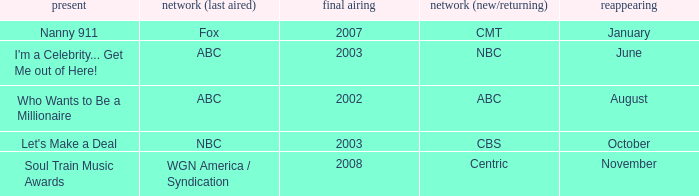What show was played on ABC laster after 2002? I'm a Celebrity... Get Me out of Here!. 